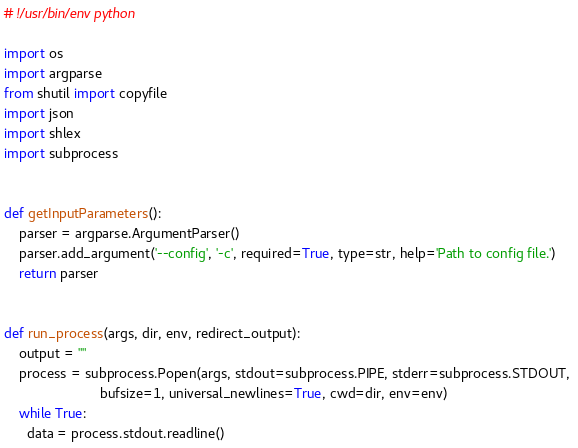<code> <loc_0><loc_0><loc_500><loc_500><_Python_># !/usr/bin/env python

import os
import argparse
from shutil import copyfile
import json
import shlex
import subprocess


def getInputParameters():
    parser = argparse.ArgumentParser()
    parser.add_argument('--config', '-c', required=True, type=str, help='Path to config file.')
    return parser


def run_process(args, dir, env, redirect_output):
    output = ""
    process = subprocess.Popen(args, stdout=subprocess.PIPE, stderr=subprocess.STDOUT, 
                         bufsize=1, universal_newlines=True, cwd=dir, env=env) 
    while True:
      data = process.stdout.readline()</code> 